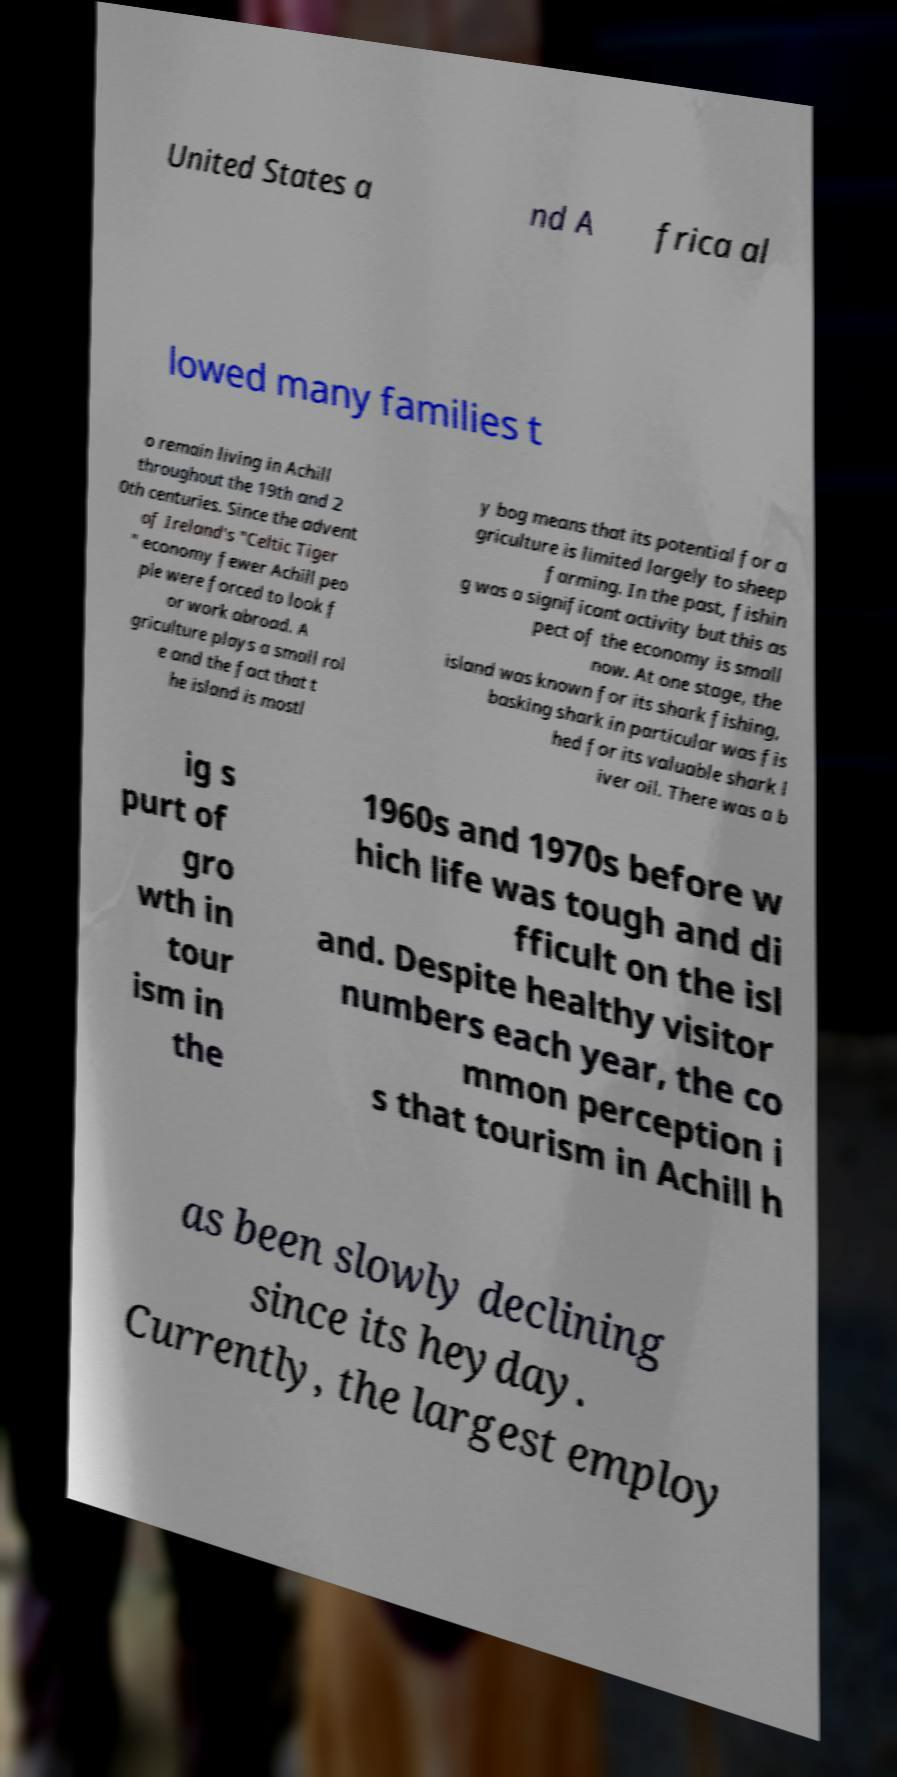Can you accurately transcribe the text from the provided image for me? United States a nd A frica al lowed many families t o remain living in Achill throughout the 19th and 2 0th centuries. Since the advent of Ireland's "Celtic Tiger " economy fewer Achill peo ple were forced to look f or work abroad. A griculture plays a small rol e and the fact that t he island is mostl y bog means that its potential for a griculture is limited largely to sheep farming. In the past, fishin g was a significant activity but this as pect of the economy is small now. At one stage, the island was known for its shark fishing, basking shark in particular was fis hed for its valuable shark l iver oil. There was a b ig s purt of gro wth in tour ism in the 1960s and 1970s before w hich life was tough and di fficult on the isl and. Despite healthy visitor numbers each year, the co mmon perception i s that tourism in Achill h as been slowly declining since its heyday. Currently, the largest employ 